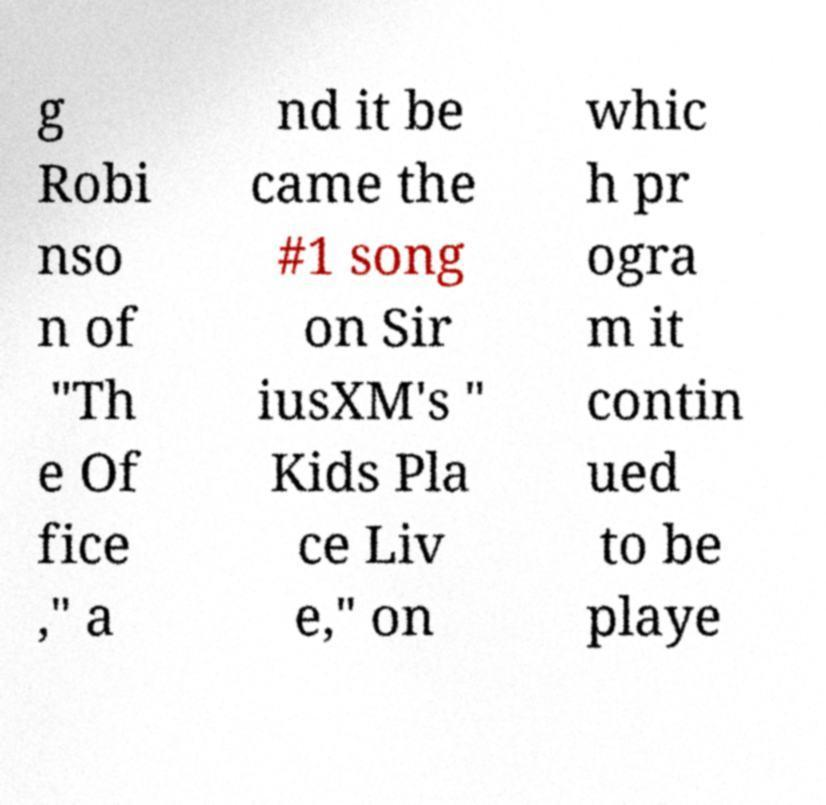For documentation purposes, I need the text within this image transcribed. Could you provide that? g Robi nso n of "Th e Of fice ," a nd it be came the #1 song on Sir iusXM's " Kids Pla ce Liv e," on whic h pr ogra m it contin ued to be playe 